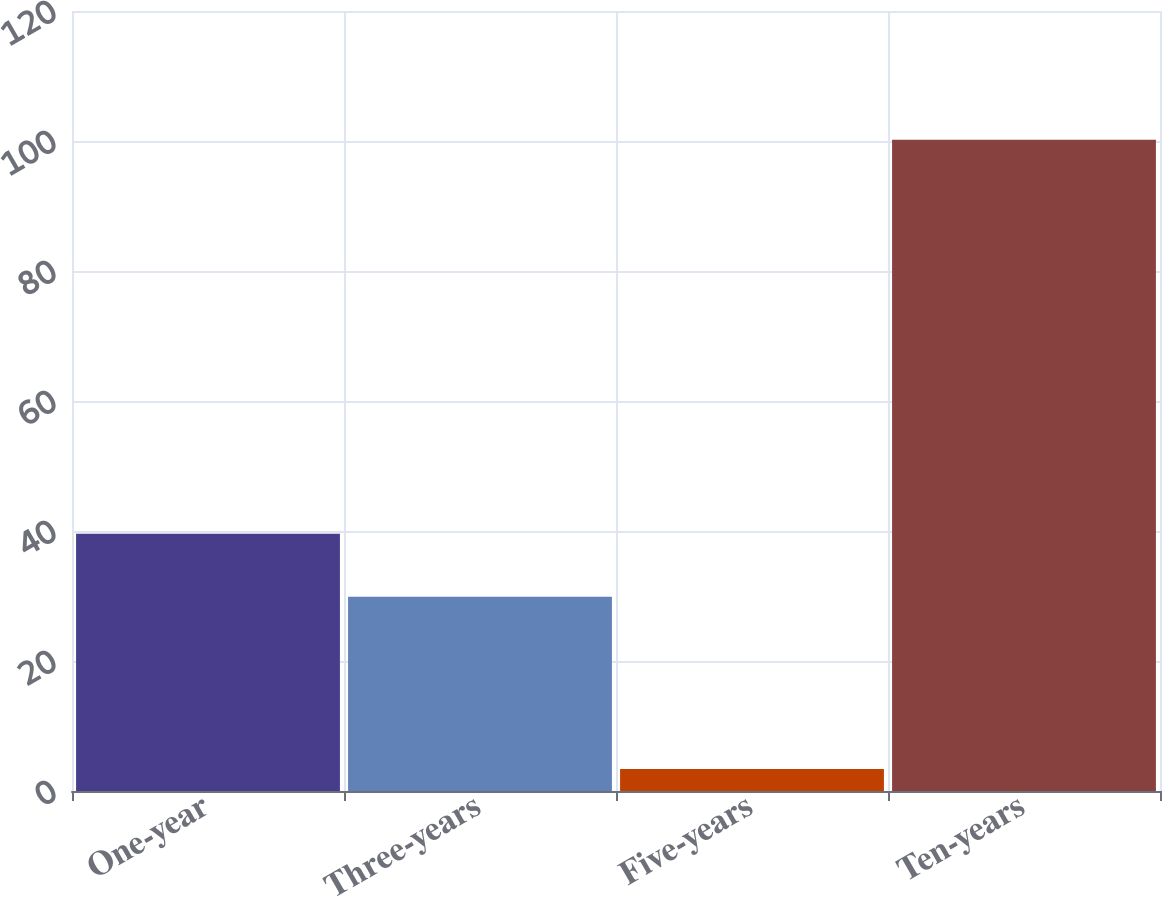Convert chart. <chart><loc_0><loc_0><loc_500><loc_500><bar_chart><fcel>One-year<fcel>Three-years<fcel>Five-years<fcel>Ten-years<nl><fcel>39.58<fcel>29.9<fcel>3.4<fcel>100.2<nl></chart> 